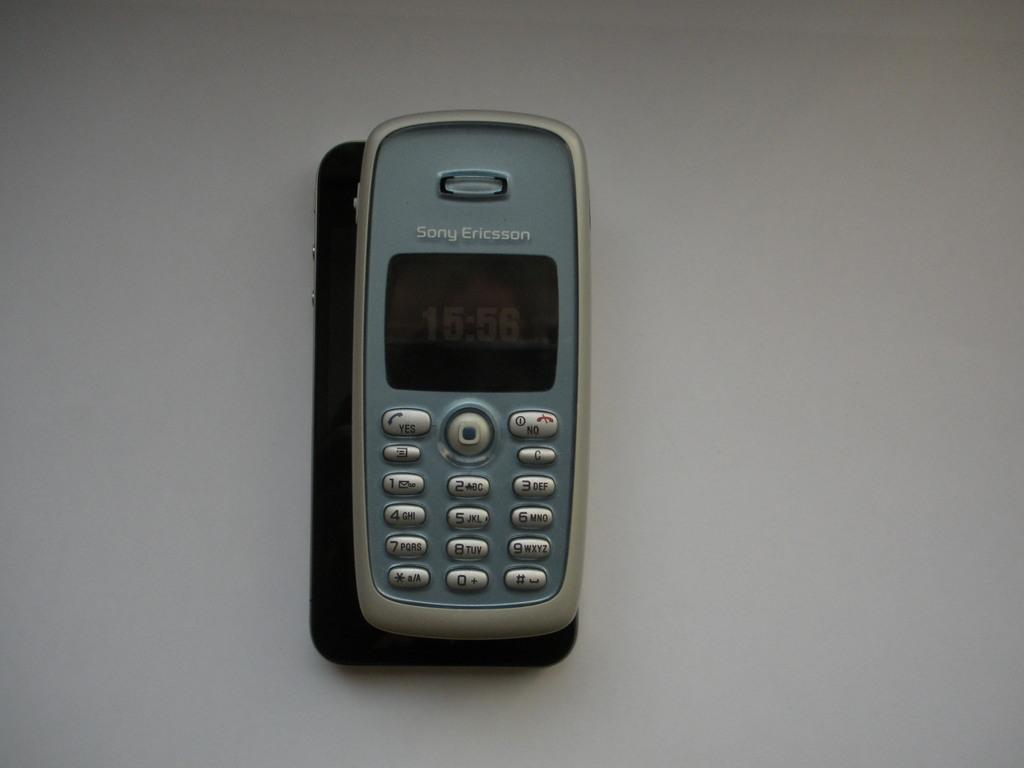<image>
Describe the image concisely. a phone that has the word sony at the top 